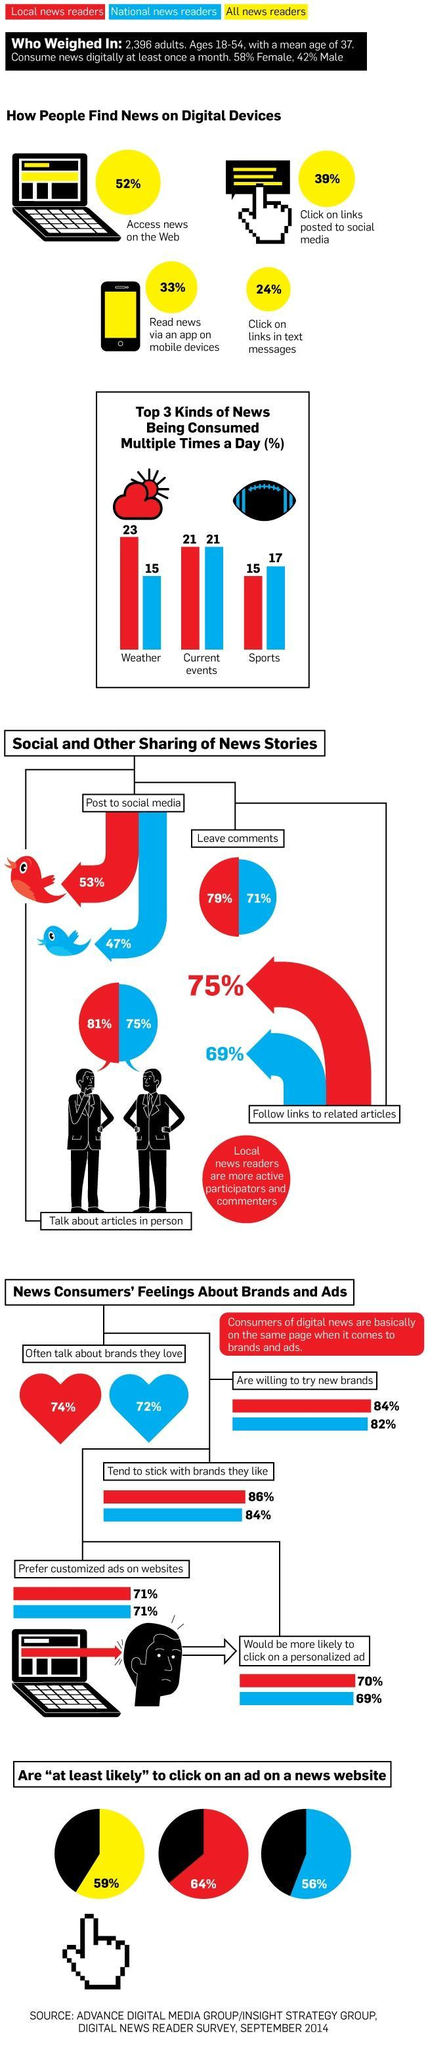What percent of national news readers aged 18-54 years talk about articles in person according to the survey?
Answer the question with a short phrase. 75% What percent of local news readers aged 18-54 years read sport news multiple times in a day according to the survey? 15 What percent of all news readers aged 18-54 years read news through an app on mobile devices according to the survey? 33% What percent of national news readers aged 18-54 years post news stories to social media according to the survey? 47% What percent of all news readers aged 18-54 years access news on the web according to the survey? 52% What percent of men aged 18-54 years consume news digitally at least once in a month? 42% What percent of local news readers aged 18-54 years follow links to related articles according to the survey? 75% What percent of local news readers aged 18-54 years often talk about brands they love as per the survey? 74% What percent of national news readers aged 18-54 years are more likely to click on a personalized ad according to the survey? 69% What percent of local news readers aged 18-54 years are willing to try new brands as per the survey? 84% 